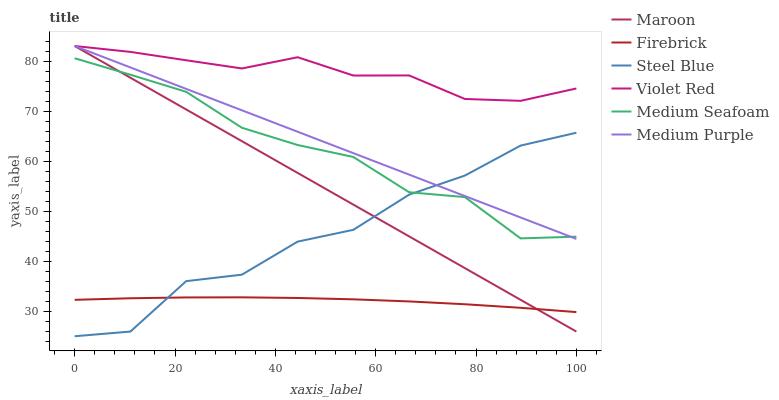Does Firebrick have the minimum area under the curve?
Answer yes or no. Yes. Does Violet Red have the maximum area under the curve?
Answer yes or no. Yes. Does Steel Blue have the minimum area under the curve?
Answer yes or no. No. Does Steel Blue have the maximum area under the curve?
Answer yes or no. No. Is Medium Purple the smoothest?
Answer yes or no. Yes. Is Steel Blue the roughest?
Answer yes or no. Yes. Is Firebrick the smoothest?
Answer yes or no. No. Is Firebrick the roughest?
Answer yes or no. No. Does Steel Blue have the lowest value?
Answer yes or no. Yes. Does Firebrick have the lowest value?
Answer yes or no. No. Does Medium Purple have the highest value?
Answer yes or no. Yes. Does Steel Blue have the highest value?
Answer yes or no. No. Is Medium Seafoam less than Violet Red?
Answer yes or no. Yes. Is Violet Red greater than Medium Seafoam?
Answer yes or no. Yes. Does Maroon intersect Violet Red?
Answer yes or no. Yes. Is Maroon less than Violet Red?
Answer yes or no. No. Is Maroon greater than Violet Red?
Answer yes or no. No. Does Medium Seafoam intersect Violet Red?
Answer yes or no. No. 